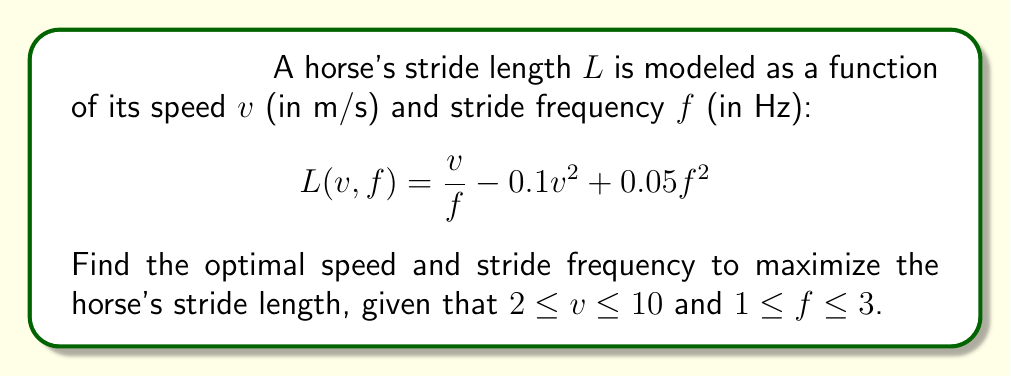Solve this math problem. To find the optimal speed and stride frequency, we need to use multivariable calculus:

1) First, find the partial derivatives of $L$ with respect to $v$ and $f$:

   $$\frac{\partial L}{\partial v} = \frac{1}{f} - 0.2v$$
   $$\frac{\partial L}{\partial f} = -\frac{v}{f^2} + 0.1f$$

2) Set both partial derivatives to zero to find critical points:

   $$\frac{1}{f} - 0.2v = 0$$
   $$-\frac{v}{f^2} + 0.1f = 0$$

3) From the first equation:
   $$v = \frac{5}{f}$$

4) Substitute this into the second equation:

   $$-\frac{5/f}{f^2} + 0.1f = 0$$
   $$-\frac{5}{f^3} + 0.1f = 0$$
   $$0.1f^4 = 5$$
   $$f^4 = 50$$
   $$f = \sqrt[4]{50} \approx 2.66$$

5) Substitute this back to find $v$:

   $$v = \frac{5}{2.66} \approx 1.88$$

6) However, we need to check if this point is within our constraints:
   $2 \leq v \leq 10$ and $1 \leq f \leq 3$

   The found $f$ is within range, but $v$ is not.

7) Since $v$ is below the lower bound, we set $v = 2$ (the closest allowed value) and solve for $f$:

   $$-\frac{2}{f^2} + 0.1f = 0$$
   $$0.1f^3 = 2$$
   $$f^3 = 20$$
   $$f = \sqrt[3]{20} \approx 2.71$$

8) Finally, we need to check the boundary points:
   $(2, 1)$, $(2, 3)$, $(10, 1)$, $(10, 3)$

   Evaluating $L$ at these points and our found point $(2, 2.71)$:

   $L(2, 1) = 1.6$
   $L(2, 3) = 0.13$
   $L(10, 1) = 0$
   $L(10, 3) = -6.53$
   $L(2, 2.71) = 0.74$

Therefore, the maximum stride length occurs at $(2, 1)$.
Answer: $v = 2$ m/s, $f = 1$ Hz 